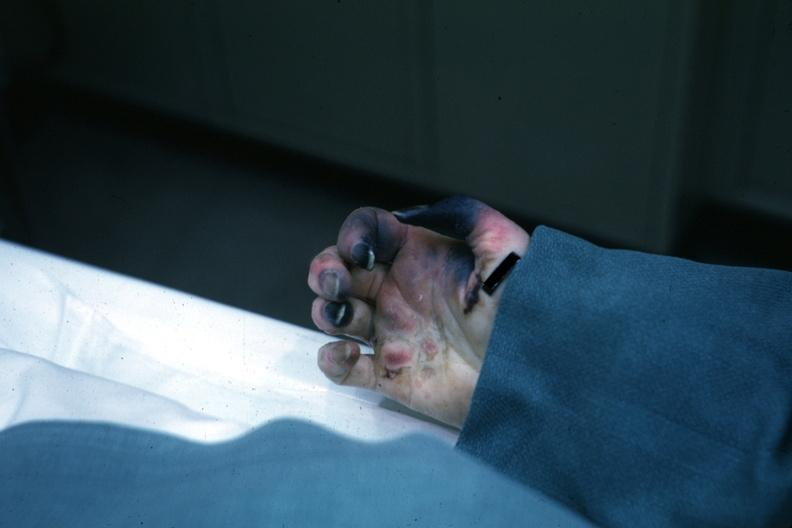what are present?
Answer the question using a single word or phrase. Extremities 